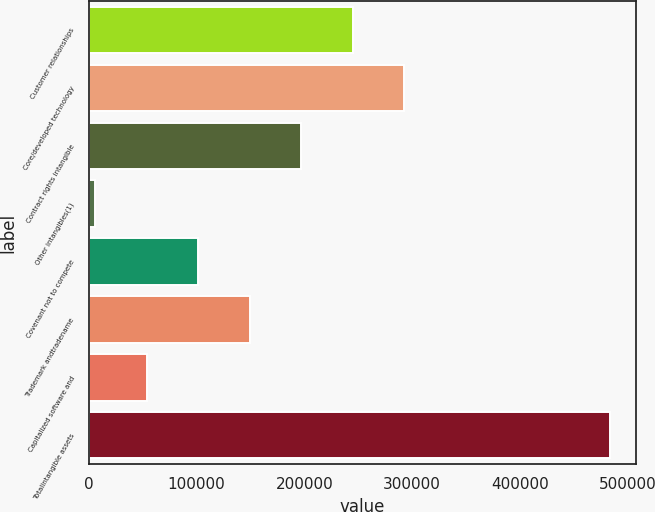Convert chart to OTSL. <chart><loc_0><loc_0><loc_500><loc_500><bar_chart><fcel>Customer relationships<fcel>Core/developed technology<fcel>Contract rights intangible<fcel>Other intangibles(1)<fcel>Covenant not to compete<fcel>Trademark andtradename<fcel>Capitalized software and<fcel>Totalintangible assets<nl><fcel>245000<fcel>292785<fcel>197215<fcel>6076<fcel>101646<fcel>149430<fcel>53860.8<fcel>483924<nl></chart> 